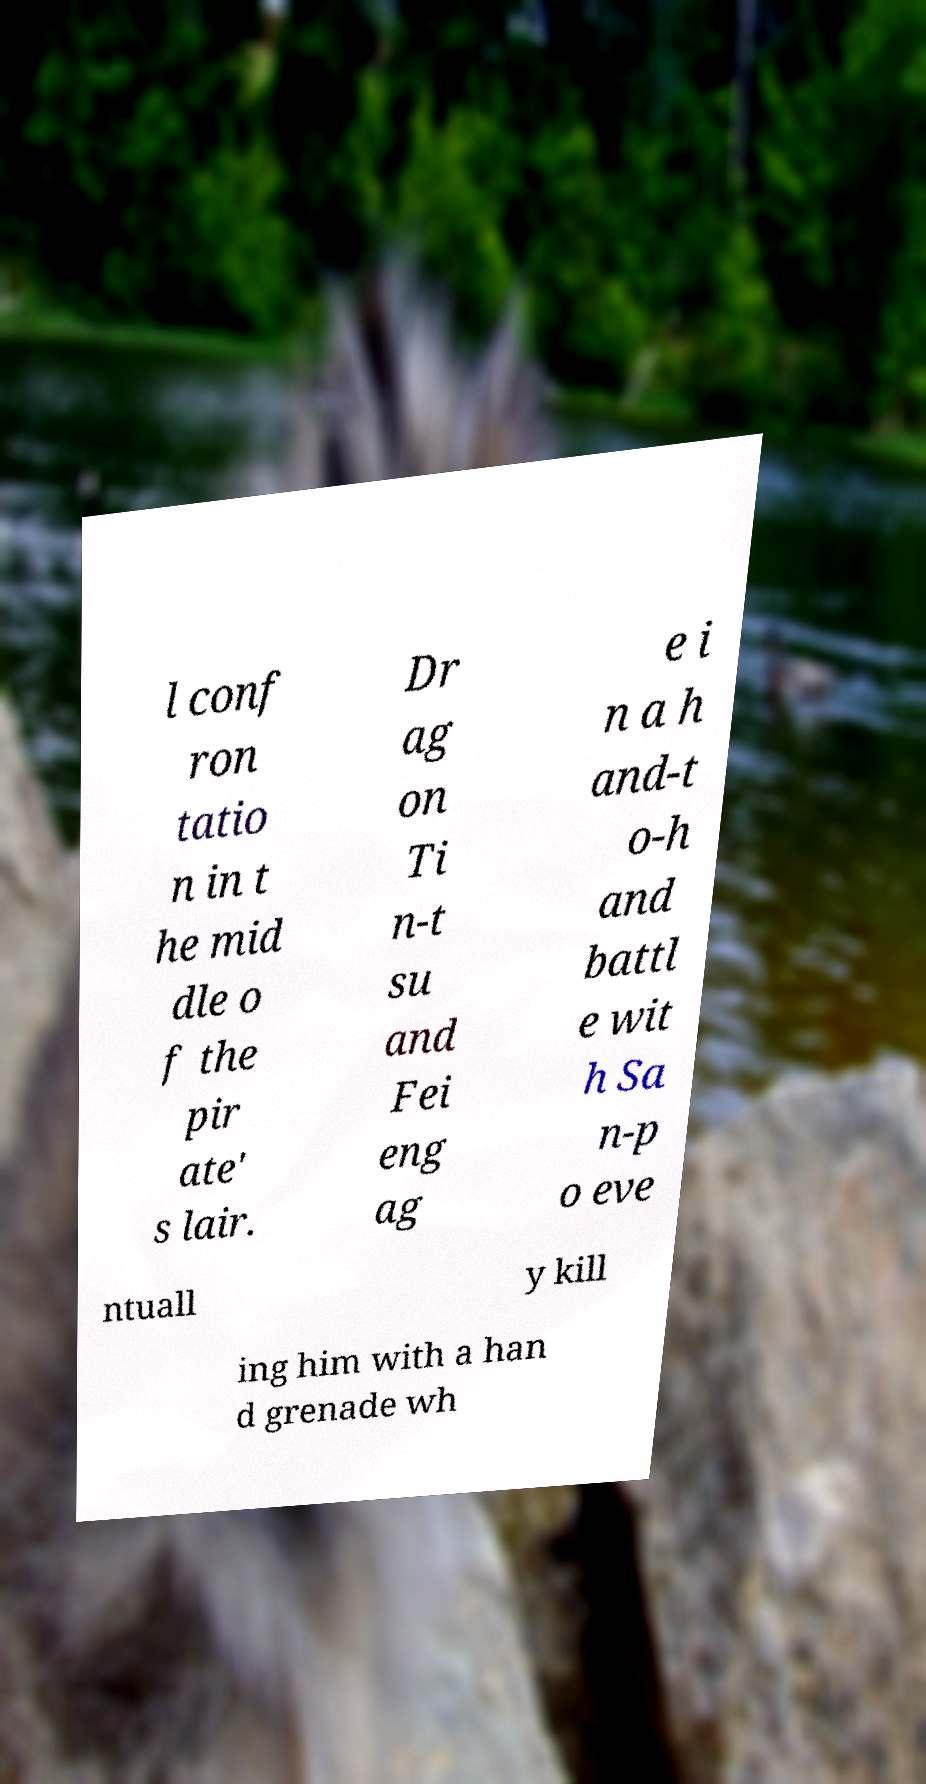Please read and relay the text visible in this image. What does it say? l conf ron tatio n in t he mid dle o f the pir ate' s lair. Dr ag on Ti n-t su and Fei eng ag e i n a h and-t o-h and battl e wit h Sa n-p o eve ntuall y kill ing him with a han d grenade wh 